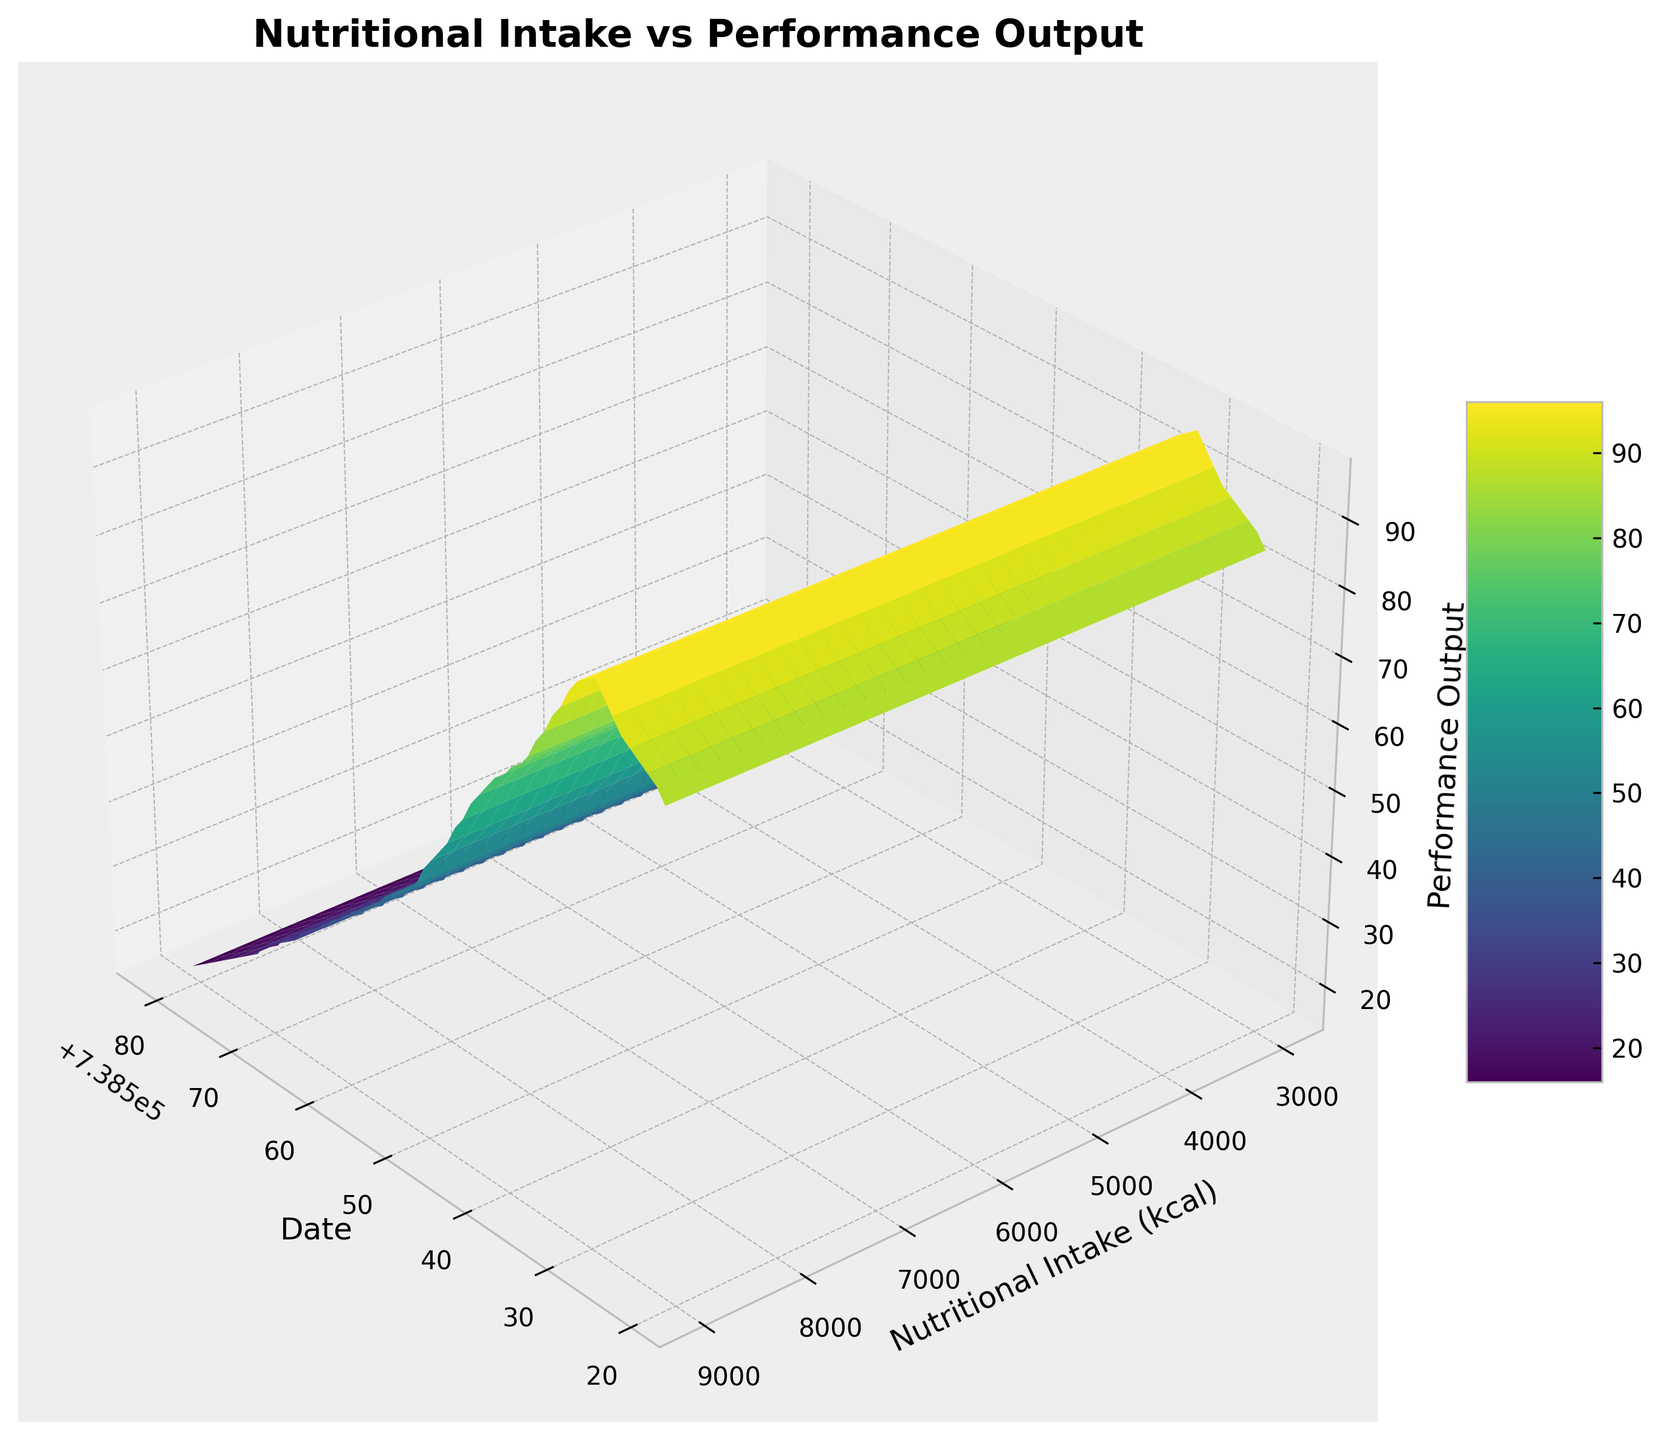When does the performance output reach its highest value? By examining the surface plot, look for the peak at the z-axis (Performance Output), and check the corresponding Date on the x-axis. Look for where the graph peaks.
Answer: January 9th How does the nutritional intake change when the performance starts to decline sharply? Identify when the decline in performance starts by looking at the z-axis for a sharp decrease. Then trace back to the y-axis to see the corresponding nutritional intake value.
Answer: It starts to decline sharply at around 3800 kcal Which period shows the steepest increase in performance output? Look for the period on the 3D surface where there's a steep incline on the z-axis (Performance Output). The steepest incline will indicate the most significant increase.
Answer: January 1st to January 9th What is the nutritional intake value when the performance output is halfway between its highest and lowest values? First, find the highest (97) and lowest (15) performance outputs. Calculate halfway: (97 - 15) / 2 + 15 = 56. Then find the corresponding y-value (Nutritional Intake) for Performance Output of 56.
Answer: Around 5800 kcal How does performance output vary with nutritional intake on February 2nd? Look along the Date axis for February 2nd, then check the surface plot to observe the fluctuations in z-axis values (Performance Output) along the nutritional intake.
Answer: It decreases around to 48 Is there a period where increasing nutritional intake leads to a steady performance output? Inspect the surface plot for horizontal sections along the y-axis (Nutritional Intake) where the z-axis (Performance Output) stays relatively constant.
Answer: After January 10th to 15th in some sections What is the performance trend when nutritional intake is between 4500 and 5000 kcal? Observe the sections on the y-axis (Nutritional Intake) between 4500 and 5000 kcal and track the changes in the z-axis (Performance Output).
Answer: Decreasing Which date corresponds to the lowest performance output? Locate the lowest point on the z-axis (Performance Output) and trace it back to the corresponding value on the x-axis (Date).
Answer: March 2nd 